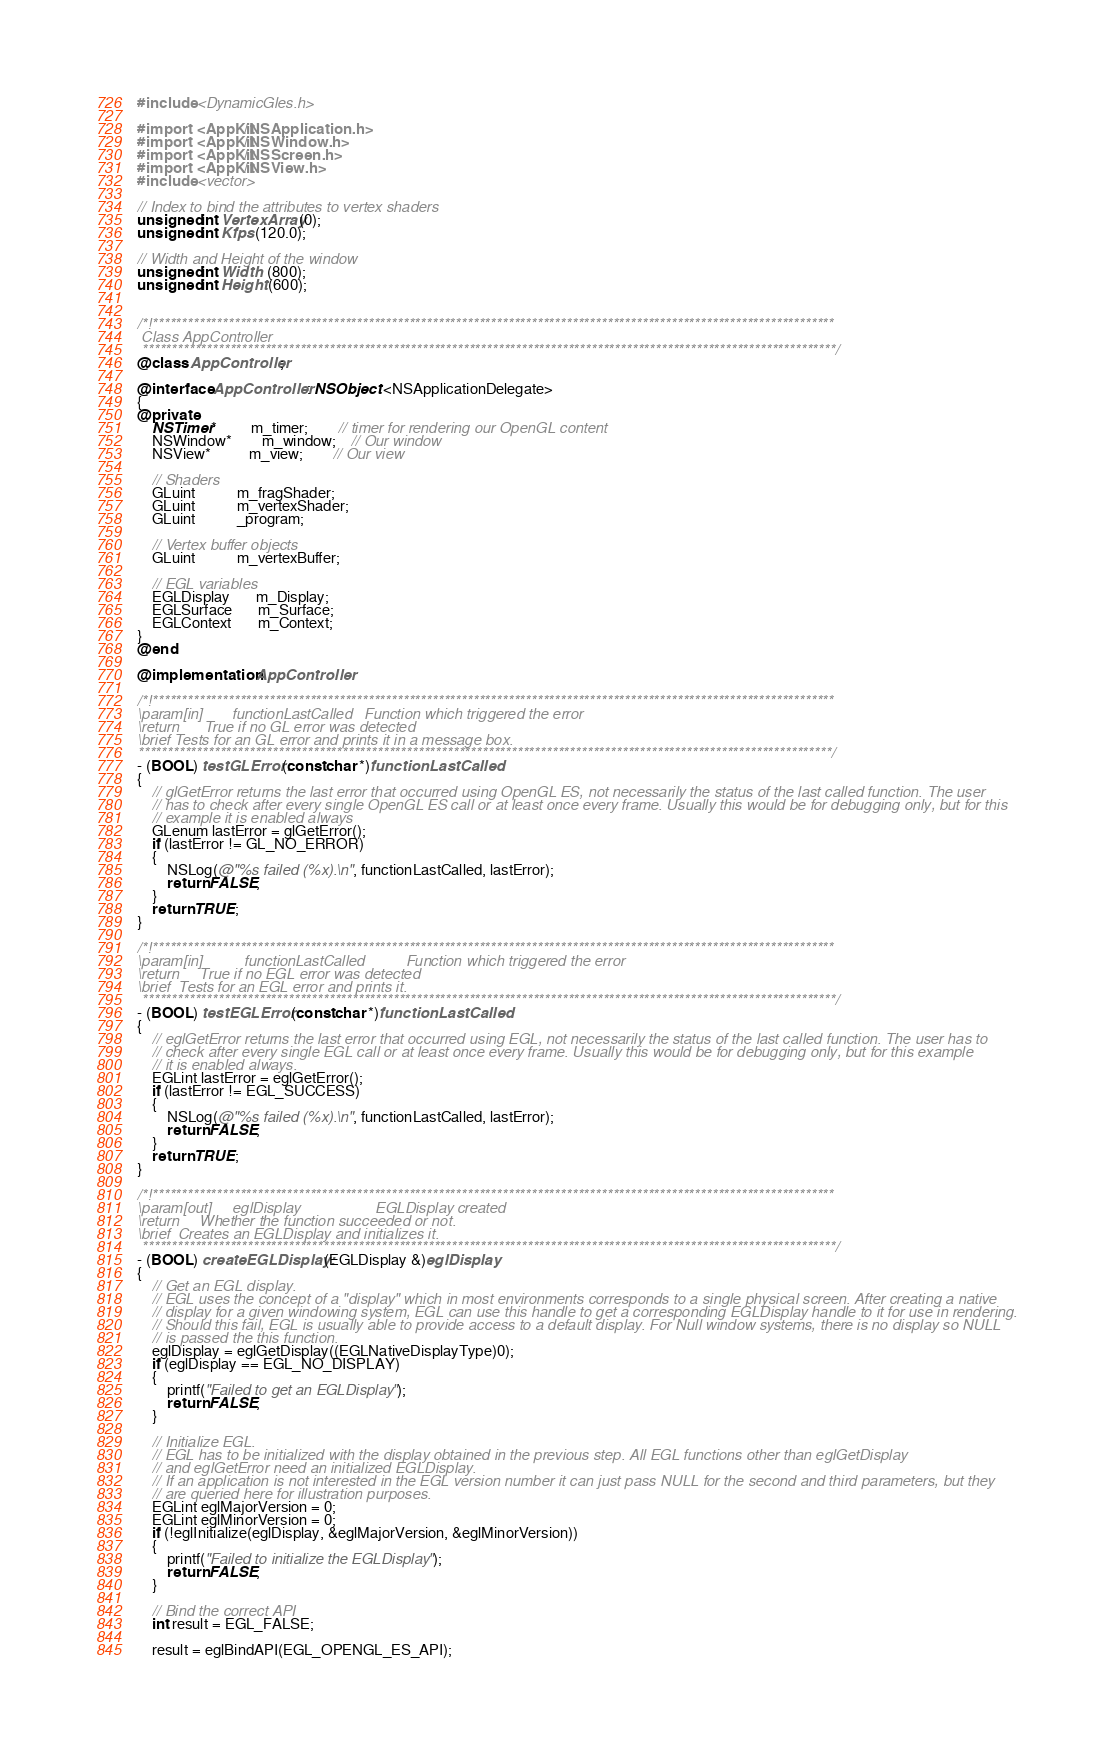<code> <loc_0><loc_0><loc_500><loc_500><_ObjectiveC_>#include <DynamicGles.h>

#import <AppKit/NSApplication.h>
#import <AppKit/NSWindow.h>
#import <AppKit/NSScreen.h>
#import <AppKit/NSView.h>
#include <vector>

// Index to bind the attributes to vertex shaders
unsigned int VertexArray(0);
unsigned int Kfps (120.0);

// Width and Height of the window
unsigned int Width  (800);
unsigned int Height (600);


/*!*********************************************************************************************************************
 Class AppController
 ***********************************************************************************************************************/
@class AppController;

@interface AppController : NSObject <NSApplicationDelegate>
{
@private
	NSTimer*         m_timer;		// timer for rendering our OpenGL content
	NSWindow*        m_window;   	// Our window
	NSView*          m_view;        // Our view
    
    // Shaders
    GLuint           m_fragShader;
    GLuint           m_vertexShader;
    GLuint           _program;
    
    // Vertex buffer objects
    GLuint           m_vertexBuffer;
    
    // EGL variables
    EGLDisplay       m_Display;
    EGLSurface       m_Surface;
    EGLContext       m_Context;
}
@end

@implementation AppController

/*!*********************************************************************************************************************
\param[in]		 functionLastCalled   Function which triggered the error
\return		 True if no GL error was detected
\brief Tests for an GL error and prints it in a message box.
***********************************************************************************************************************/
- (BOOL) testGLError:(const char *)functionLastCalled
{
	// glGetError returns the last error that occurred using OpenGL ES, not necessarily the status of the last called function. The user
	// has to check after every single OpenGL ES call or at least once every frame. Usually this would be for debugging only, but for this
	// example it is enabled always
	GLenum lastError = glGetError();
	if (lastError != GL_NO_ERROR)
	{
		NSLog(@"%s failed (%x).\n", functionLastCalled, lastError);
		return FALSE;
	}
	return TRUE;
}

/*!*********************************************************************************************************************
\param[in]			functionLastCalled          Function which triggered the error
\return		True if no EGL error was detected
\brief	Tests for an EGL error and prints it.
 ***********************************************************************************************************************/
- (BOOL) testEGLError:(const char *)functionLastCalled
{
	// eglGetError returns the last error that occurred using EGL, not necessarily the status of the last called function. The user has to
	// check after every single EGL call or at least once every frame. Usually this would be for debugging only, but for this example
	// it is enabled always.
	EGLint lastError = eglGetError();
	if (lastError != EGL_SUCCESS)
	{
		NSLog(@"%s failed (%x).\n", functionLastCalled, lastError);
		return FALSE;
	}
	return TRUE;
}

/*!*********************************************************************************************************************
\param[out]		eglDisplay				    EGLDisplay created
\return		Whether the function succeeded or not.
\brief	Creates an EGLDisplay and initializes it.
 ***********************************************************************************************************************/
- (BOOL) createEGLDisplay:(EGLDisplay &)eglDisplay
{
	// Get an EGL display.
	// EGL uses the concept of a "display" which in most environments corresponds to a single physical screen. After creating a native
	// display for a given windowing system, EGL can use this handle to get a corresponding EGLDisplay handle to it for use in rendering.
	// Should this fail, EGL is usually able to provide access to a default display. For Null window systems, there is no display so NULL
	// is passed the this function.
	eglDisplay = eglGetDisplay((EGLNativeDisplayType)0);
	if (eglDisplay == EGL_NO_DISPLAY)
	{
		printf("Failed to get an EGLDisplay");
		return FALSE;
	}

	// Initialize EGL.
	// EGL has to be initialized with the display obtained in the previous step. All EGL functions other than eglGetDisplay
	// and eglGetError need an initialized EGLDisplay.
	// If an application is not interested in the EGL version number it can just pass NULL for the second and third parameters, but they
	// are queried here for illustration purposes.
	EGLint eglMajorVersion = 0;
	EGLint eglMinorVersion = 0;
	if (!eglInitialize(eglDisplay, &eglMajorVersion, &eglMinorVersion))
	{
		printf("Failed to initialize the EGLDisplay");
		return FALSE;
	}
	
	// Bind the correct API
	int result = EGL_FALSE;

	result = eglBindAPI(EGL_OPENGL_ES_API);
</code> 